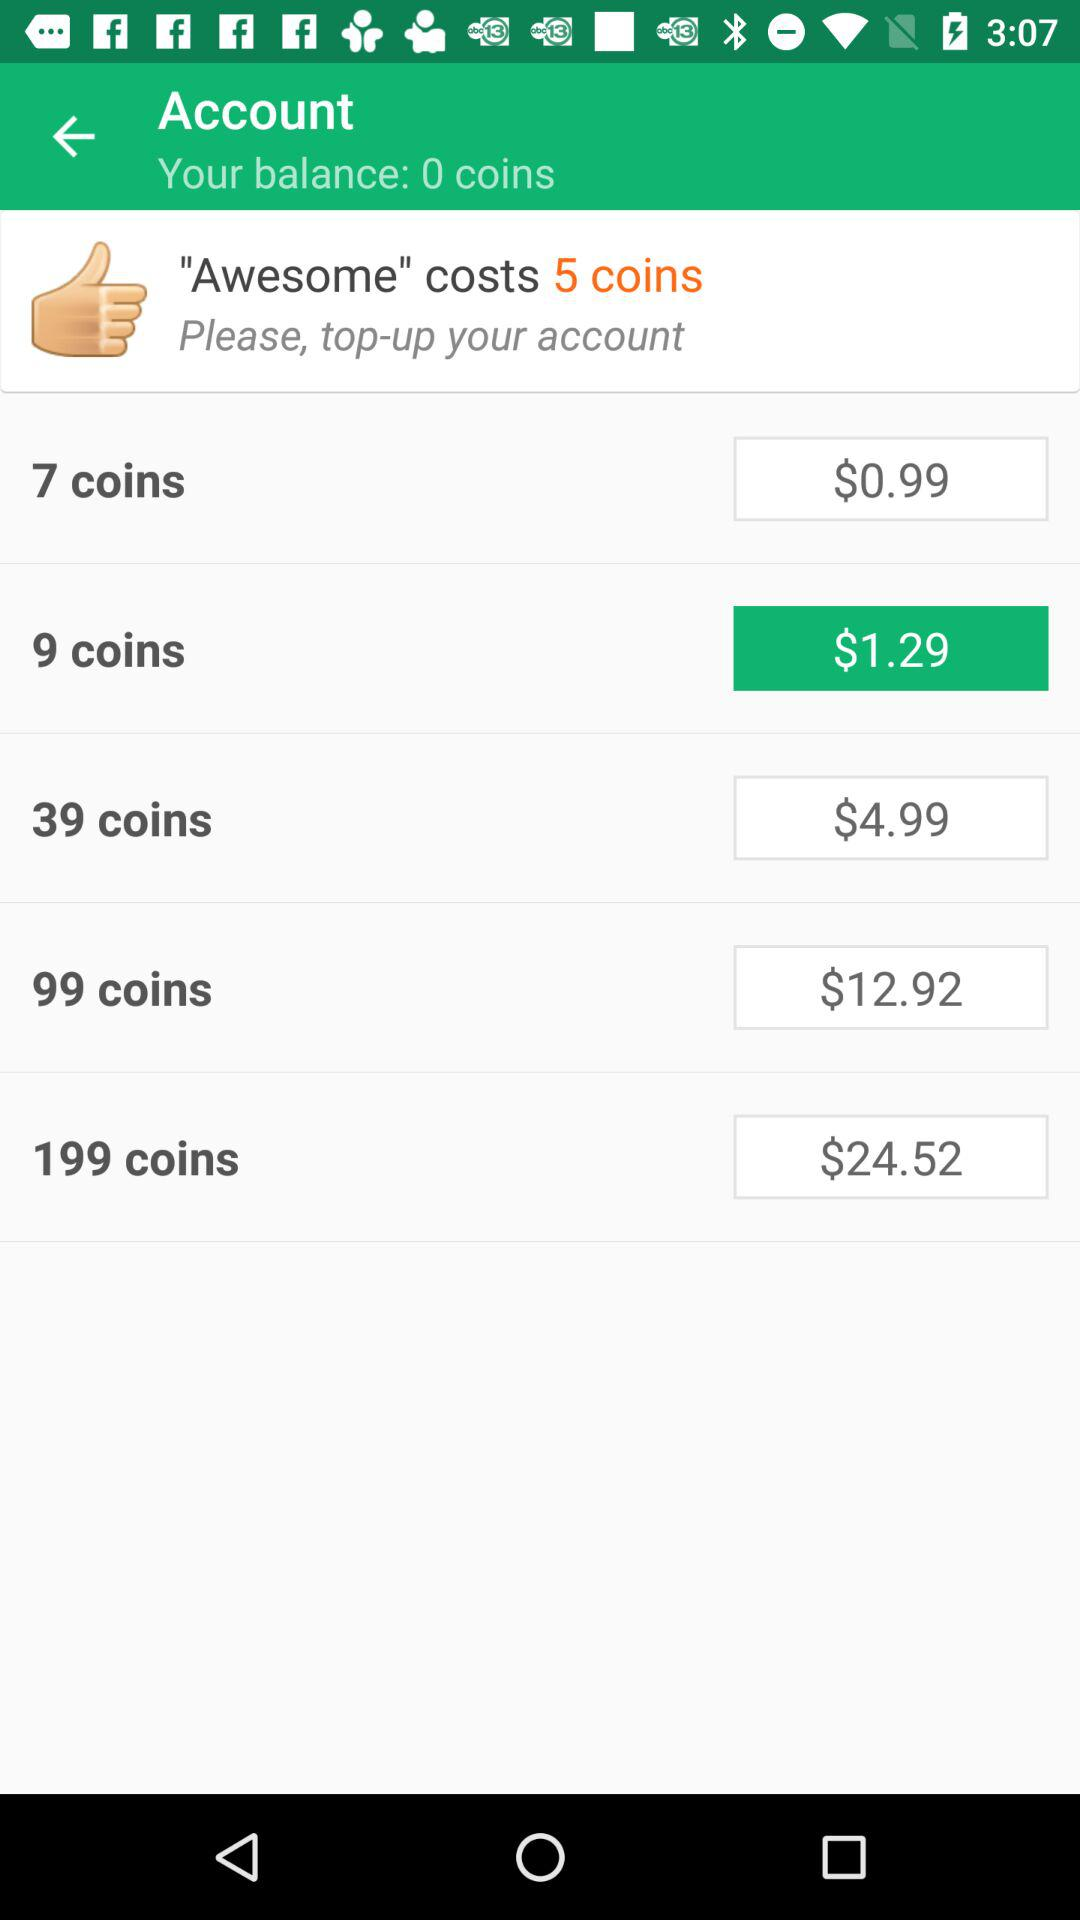What is the cost of buying 39 coins? The cost is $4.99. 